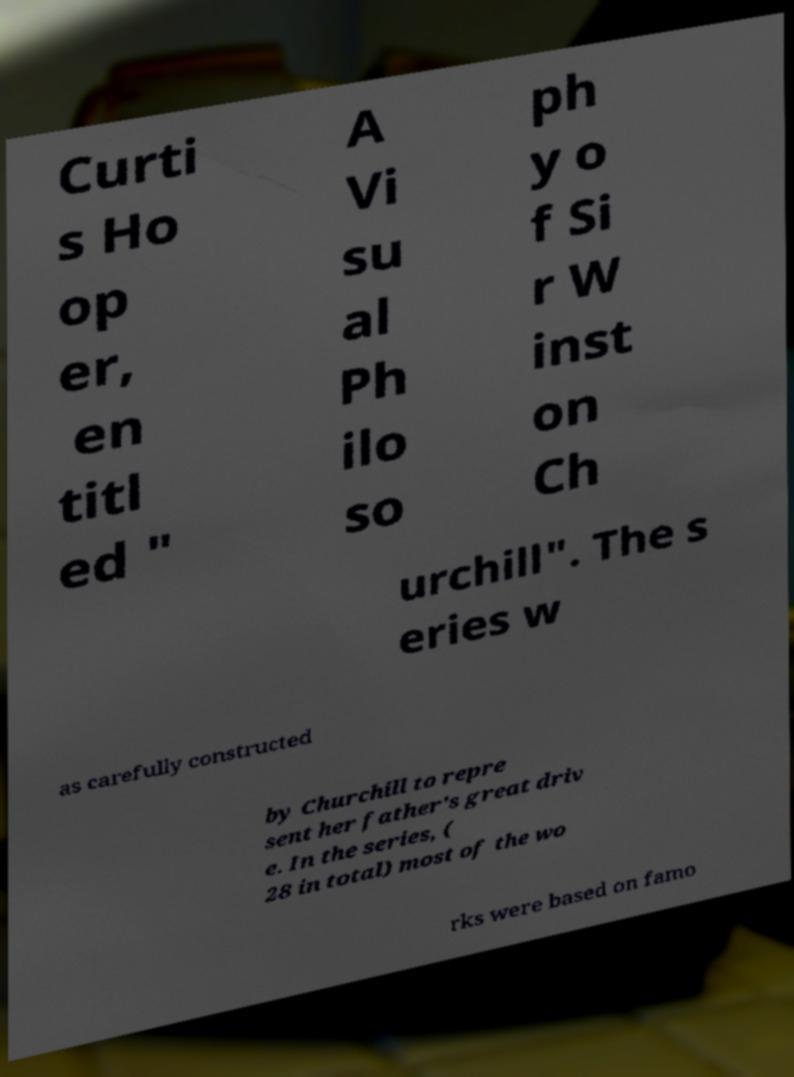There's text embedded in this image that I need extracted. Can you transcribe it verbatim? Curti s Ho op er, en titl ed " A Vi su al Ph ilo so ph y o f Si r W inst on Ch urchill". The s eries w as carefully constructed by Churchill to repre sent her father's great driv e. In the series, ( 28 in total) most of the wo rks were based on famo 